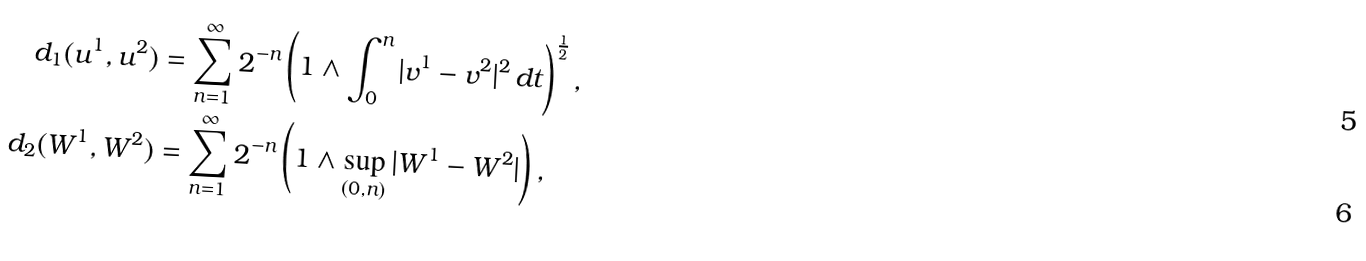Convert formula to latex. <formula><loc_0><loc_0><loc_500><loc_500>d _ { 1 } ( u ^ { 1 } , u ^ { 2 } ) & = \sum _ { n = 1 } ^ { \infty } 2 ^ { - n } \left ( 1 \wedge \int _ { 0 } ^ { n } | v ^ { 1 } - v ^ { 2 } | ^ { 2 } \, d t \right ) ^ { \frac { 1 } { 2 } } , \\ d _ { 2 } ( W ^ { 1 } , W ^ { 2 } ) & = \sum _ { n = 1 } ^ { \infty } 2 ^ { - n } \left ( 1 \wedge \sup _ { ( 0 , n ) } | W ^ { 1 } - W ^ { 2 } | \right ) ,</formula> 